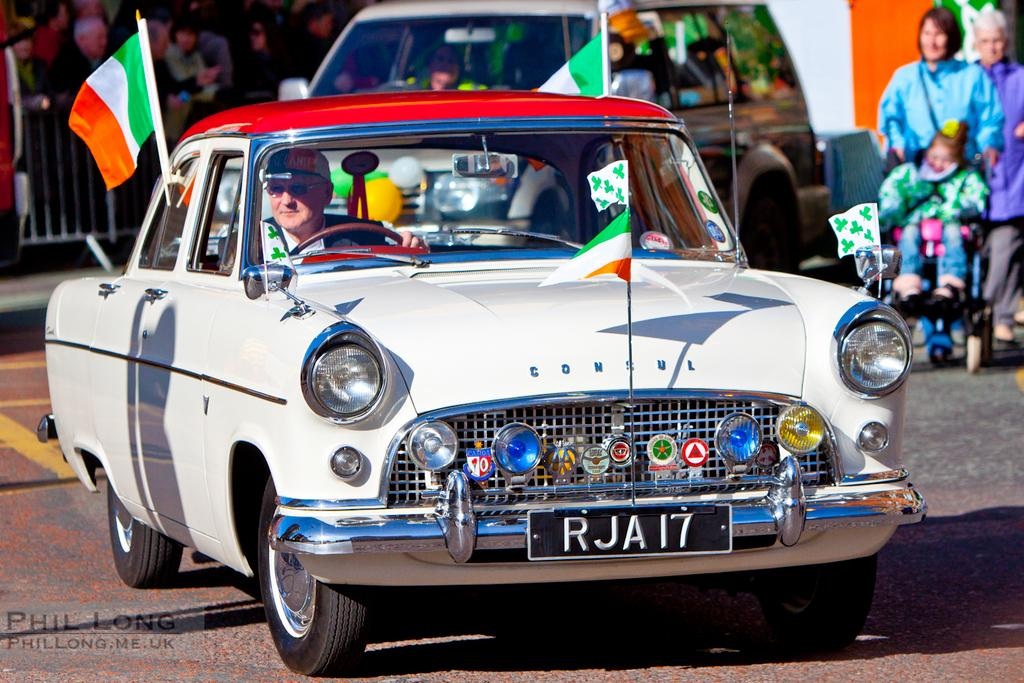What type of vehicle is in the image? There is a white car in the image. What is happening on the right side of the image? A woman is walking on the right side of the image. What is the woman wearing? The woman is wearing a blue coat. How many dimes can be seen on the ground near the woman? There are no dimes visible on the ground near the woman in the image. 